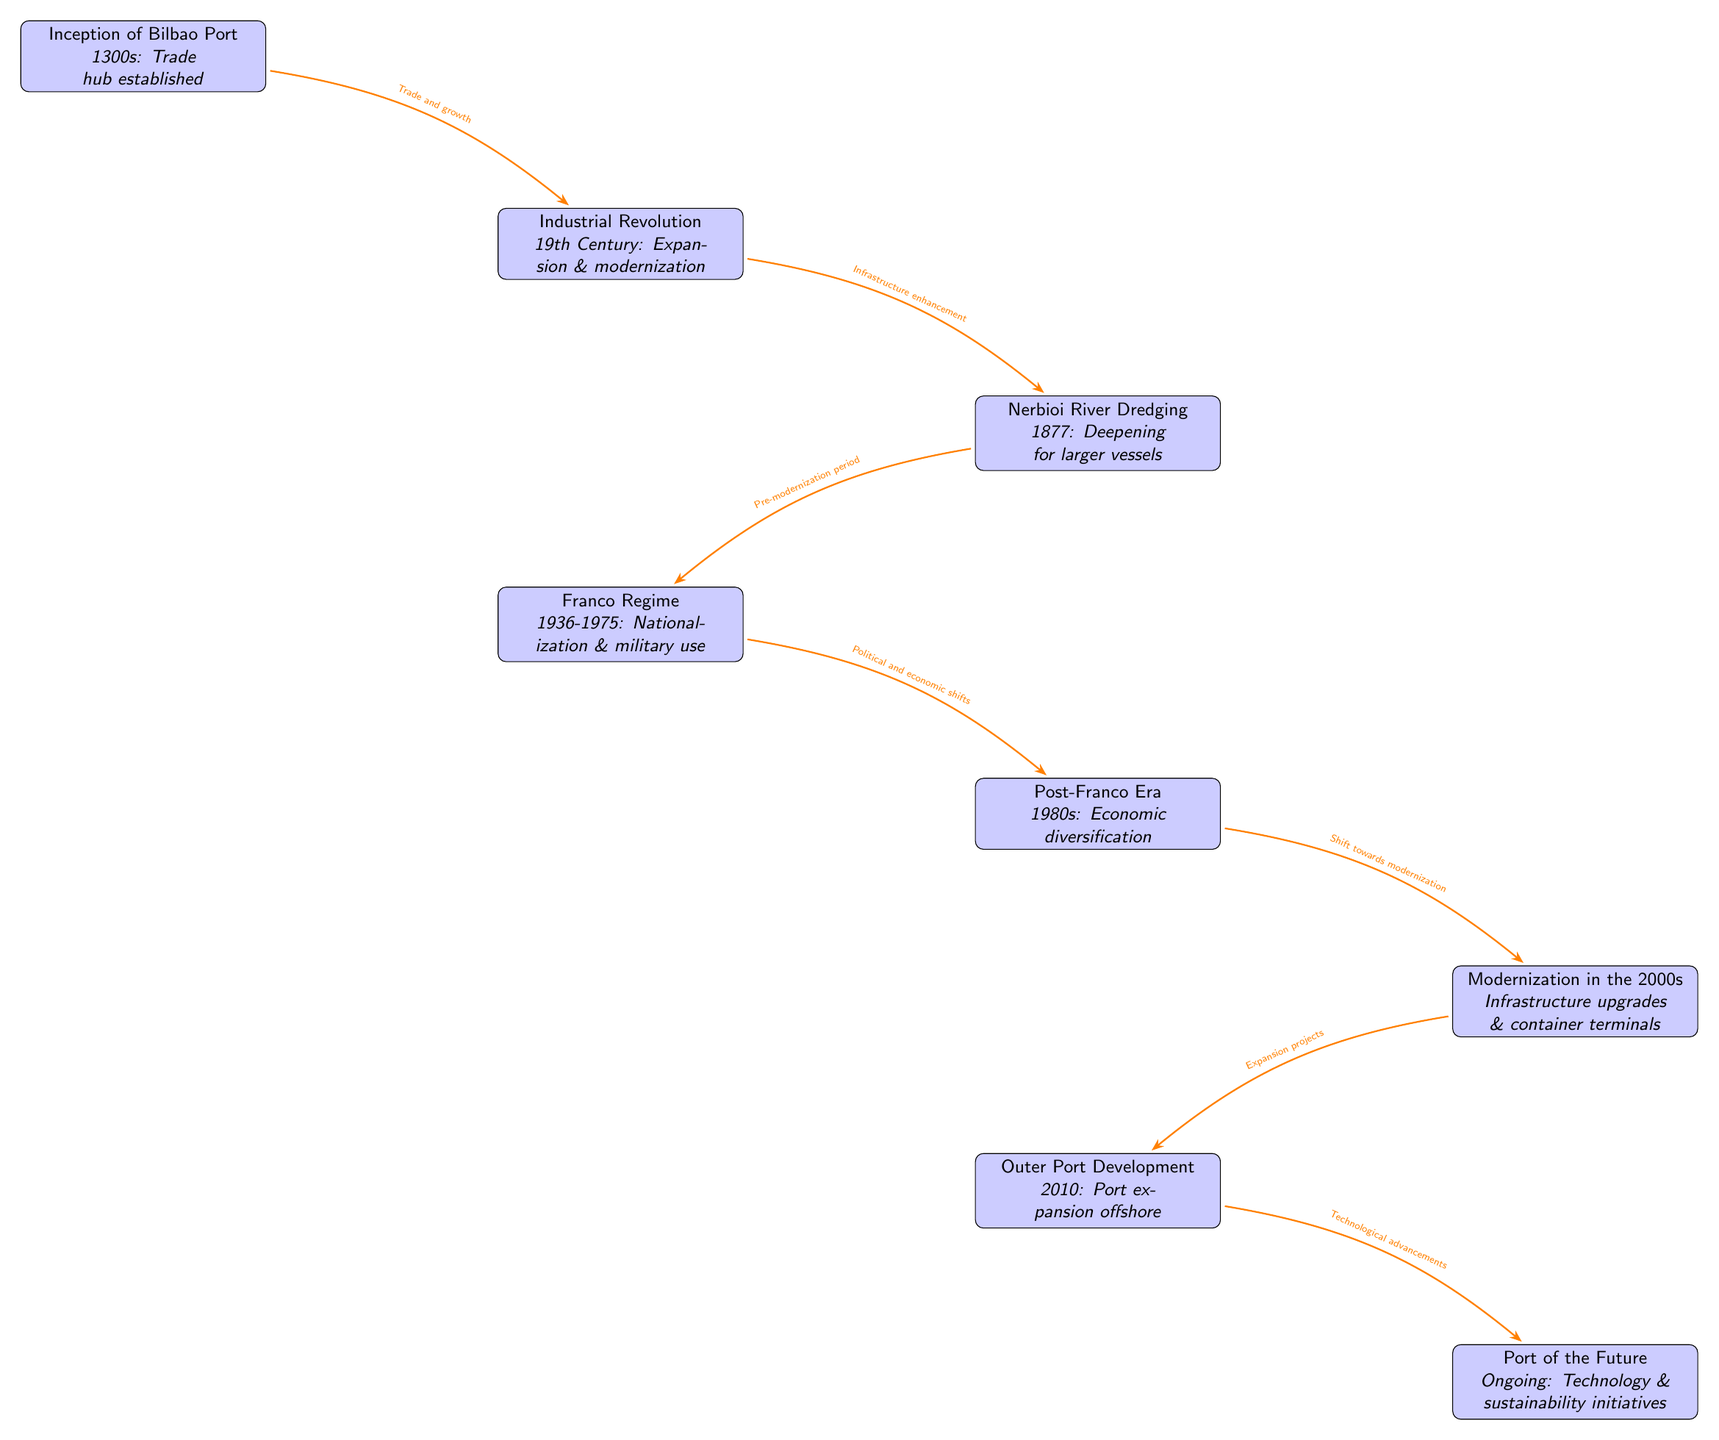What is the first event depicted in the diagram? The first event is located at the top of the diagram, labeled "Inception of Bilbao Port." It indicates that the port was established in the 1300s as a trade hub.
Answer: Inception of Bilbao Port What year did the Nerbioi River dredging take place? The year associated with the Nerbioi River dredging is directly indicated next to the event node. It states that this event occurred in 1877.
Answer: 1877 How many main events are listed in the diagram? To find the number of main events, I count the nodes from top to bottom. There are a total of seven event nodes listed in the diagram.
Answer: 7 What event occurred during the Franco regime? The node labeled "Franco Regime" specifically mentions this time period and is positioned relative to other events, indicating its role in the timeline.
Answer: Nationalization & military use What is the last event mentioned in the diagram? The last event is at the bottom of the diagram, labeled "Port of the Future." This indicates ongoing advancements happening now.
Answer: Port of the Future What shift in focus occurred as a result of the post-Franco era? Referring to the arrow that connects the "Post-Franco Era" to "Modernization," it indicates a significant shift towards economic diversification and modernization.
Answer: Economic diversification Which event was directly influenced by political and economic shifts? The arrow leading from "Franco Regime" to "Post-Franco Era" highlights that political and economic shifts contributed directly to the changes in that period.
Answer: Post-Franco Era How did the 19th Century Industrial Revolution affect the Bilbao Port? The arrow pointing from "Industrial Revolution" to "Nerbioi River Dredging" shows that this expansion and modernization directly affected the port's capacity and capabilities during that time.
Answer: Infrastructure enhancement What technological advancements are mentioned for the future of the Bilbao Port? The node labeled "Port of the Future" refers directly to technology and sustainability initiatives currently being pursued, reflecting ongoing developments in the port's future operations.
Answer: Technology & sustainability initiatives 